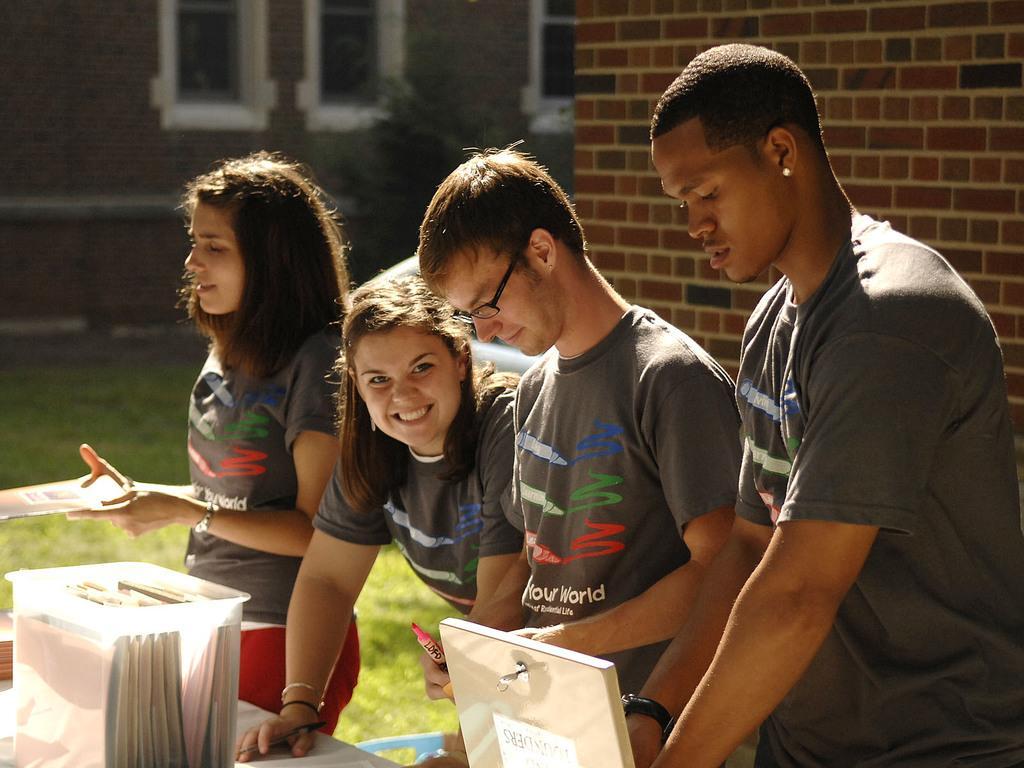How would you summarize this image in a sentence or two? In this image, There are some people standing and in the left side there is a white color box in that there are some books and in the right side there is a wall which is in brown color. 